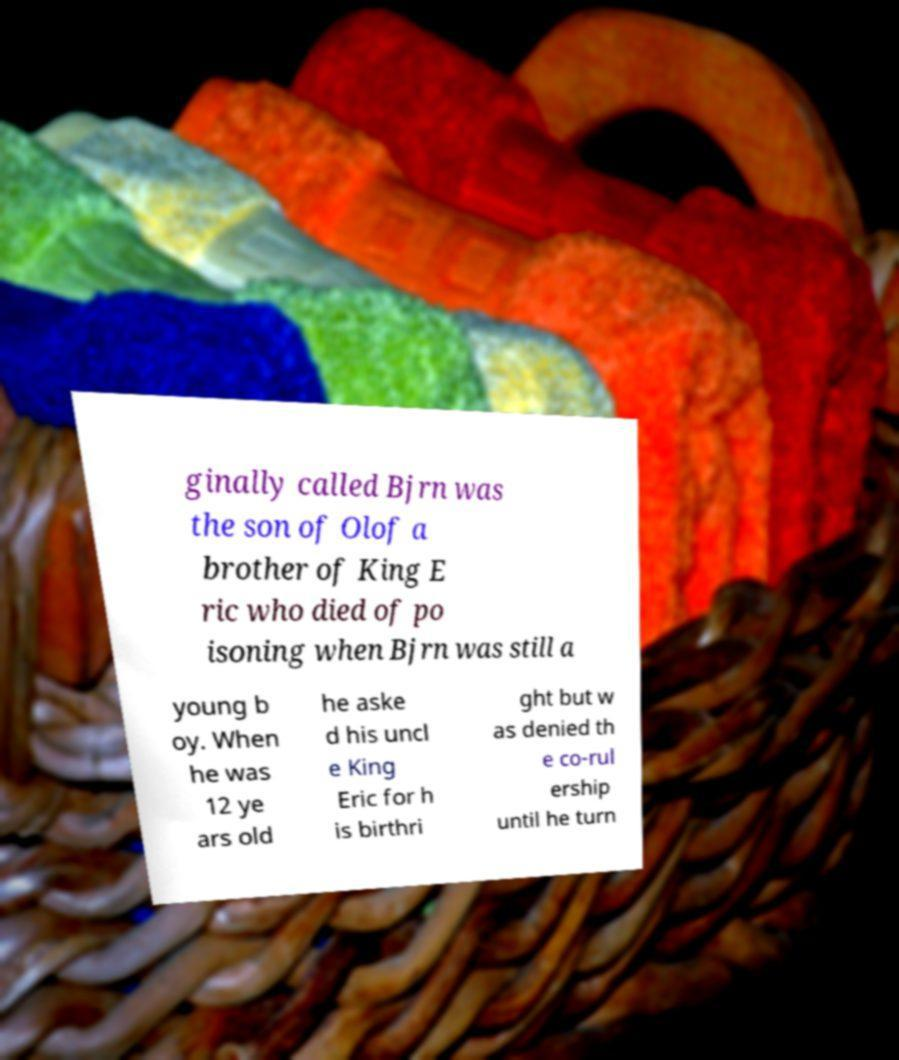For documentation purposes, I need the text within this image transcribed. Could you provide that? ginally called Bjrn was the son of Olof a brother of King E ric who died of po isoning when Bjrn was still a young b oy. When he was 12 ye ars old he aske d his uncl e King Eric for h is birthri ght but w as denied th e co-rul ership until he turn 